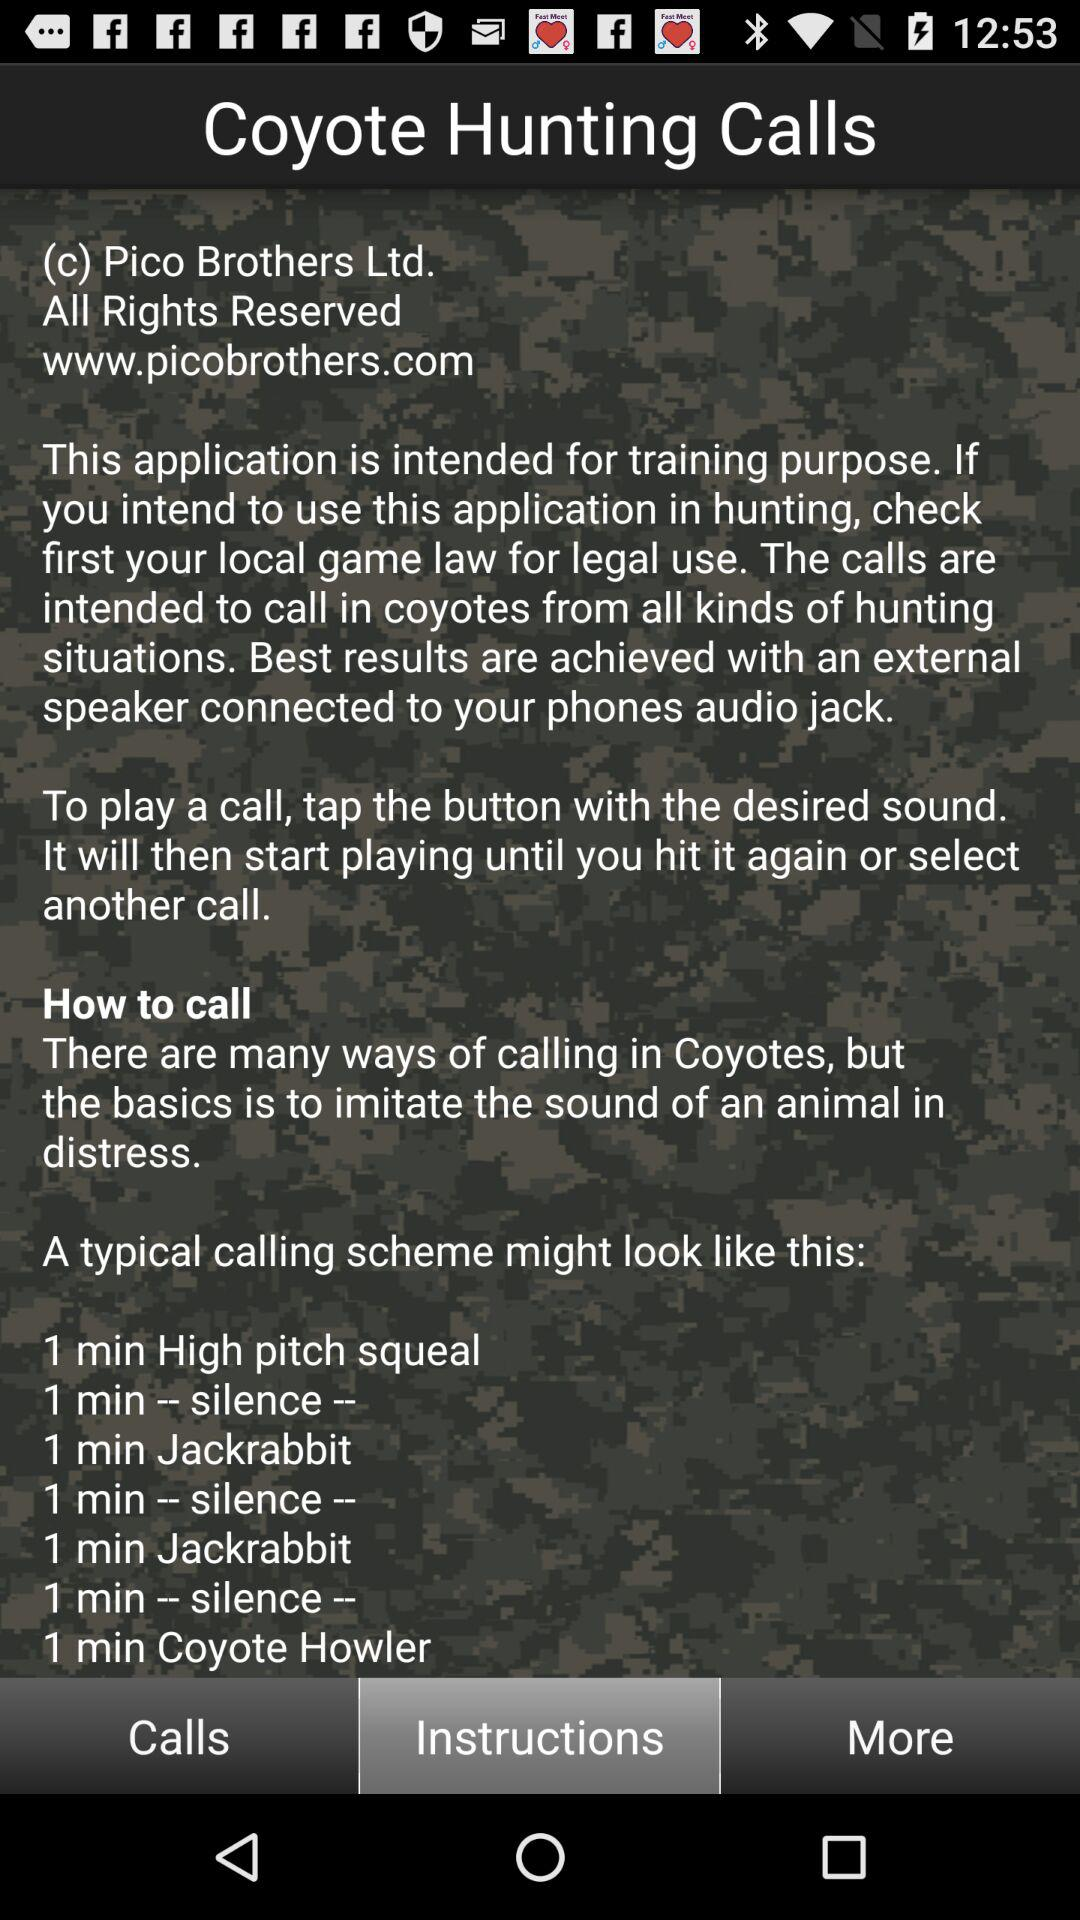What might be the reason behind the alternating patterns of calls and silence? The alternating pattern of calls and silence in the scheme is strategic. It allows time between sounds which can make the setting appear more natural and less human-manipulated, potentially increasing the chances of successfully attracting coyotes. 